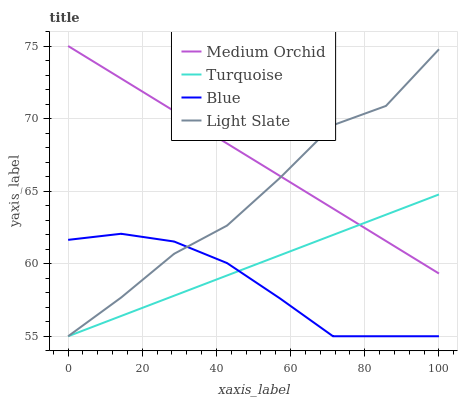Does Light Slate have the minimum area under the curve?
Answer yes or no. No. Does Light Slate have the maximum area under the curve?
Answer yes or no. No. Is Turquoise the smoothest?
Answer yes or no. No. Is Turquoise the roughest?
Answer yes or no. No. Does Medium Orchid have the lowest value?
Answer yes or no. No. Does Light Slate have the highest value?
Answer yes or no. No. Is Blue less than Medium Orchid?
Answer yes or no. Yes. Is Medium Orchid greater than Blue?
Answer yes or no. Yes. Does Blue intersect Medium Orchid?
Answer yes or no. No. 